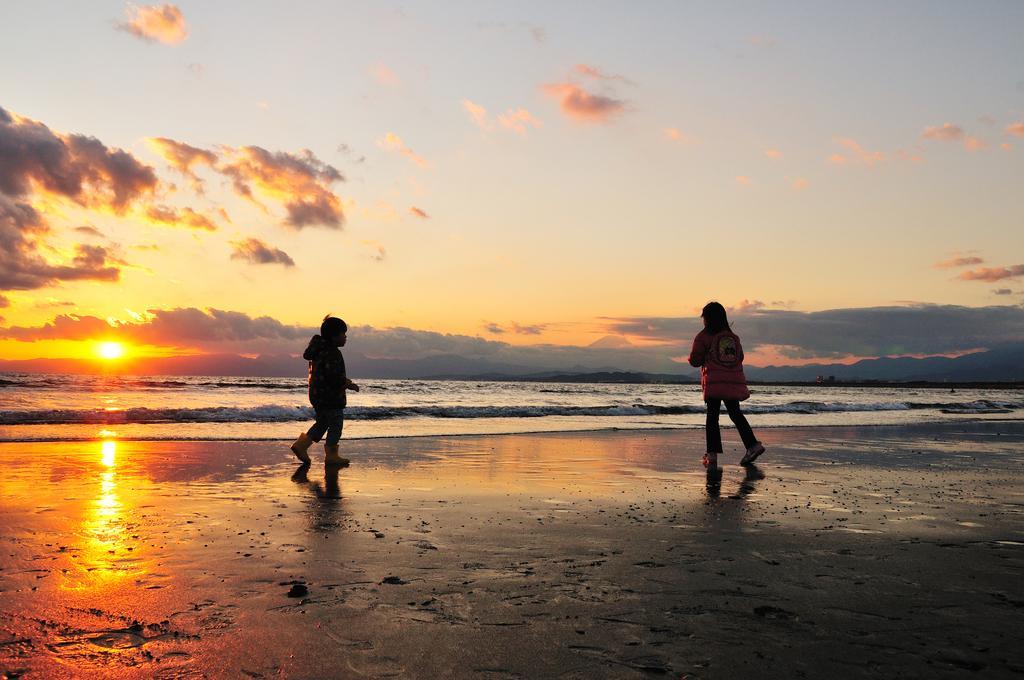Please provide a concise description of this image. In this image we can see two children are standing, in front there is the water, there is a sun in the sky. 